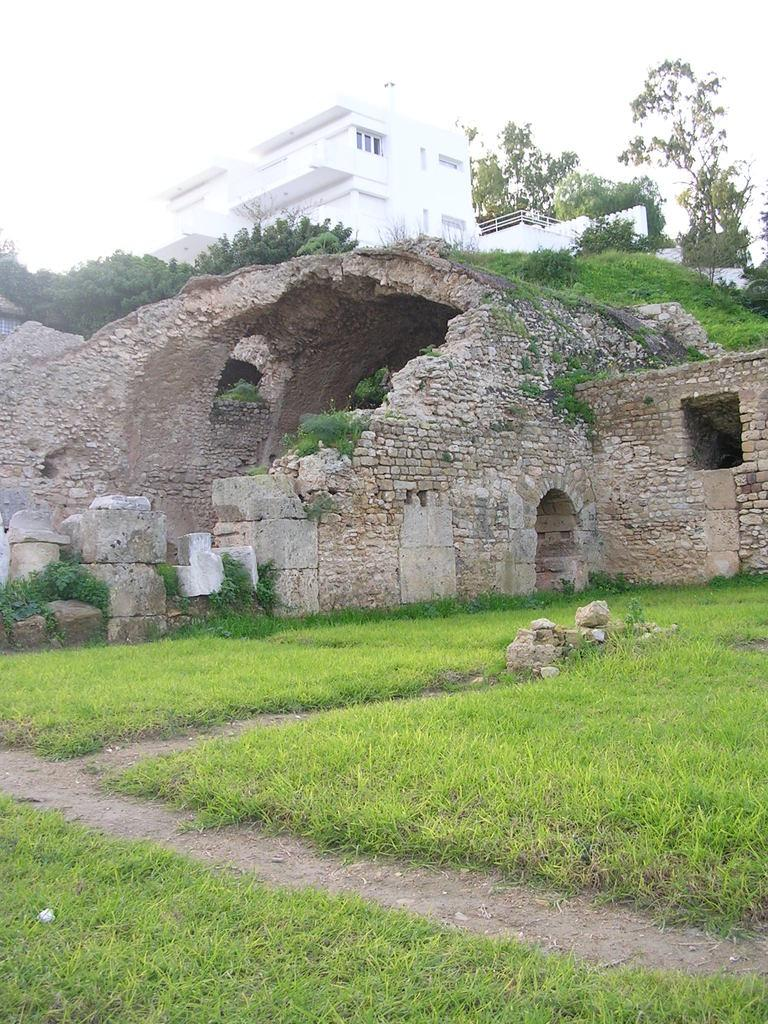What type of structure is visible in the image? There is a building in the image. What is located in front of the building? Trees are present in front of the building. What can be seen at the bottom of the image? The bottom of the image shows a destructed building, stones, and grass. What is visible at the top of the image? The sky is visible at the top of the image. How many planes can be seen taking off from the airport in the image? There is no airport or planes present in the image. Is there a hen visible in the image? There is no hen present in the image. 